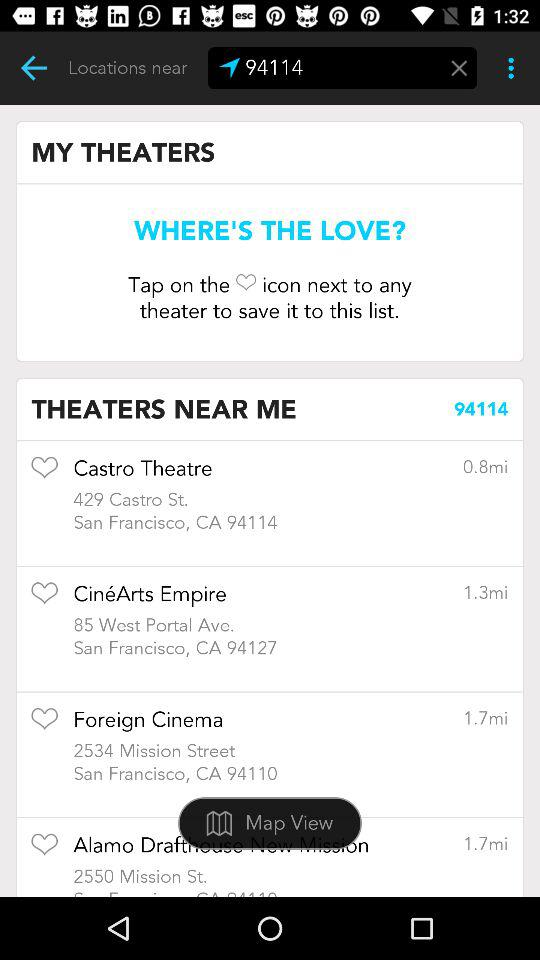What is the distance to the Castro Theatre? The Castro Theatre is 0.8 miles away. 